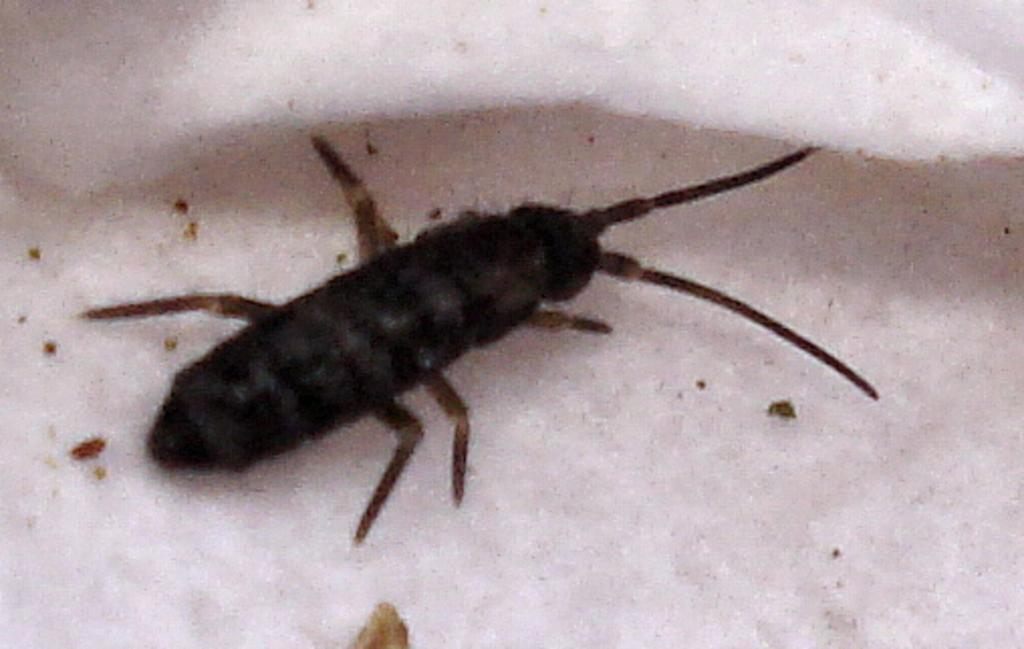What type of creature can be seen in the image? There is an insect in the image. Where is the insect located? The insect is on a surface. What type of cushion is the insect sitting on in the image? There is no cushion present in the image; the insect is on a surface. How many copies of the insect can be seen in the image? There is only one insect visible in the image. 